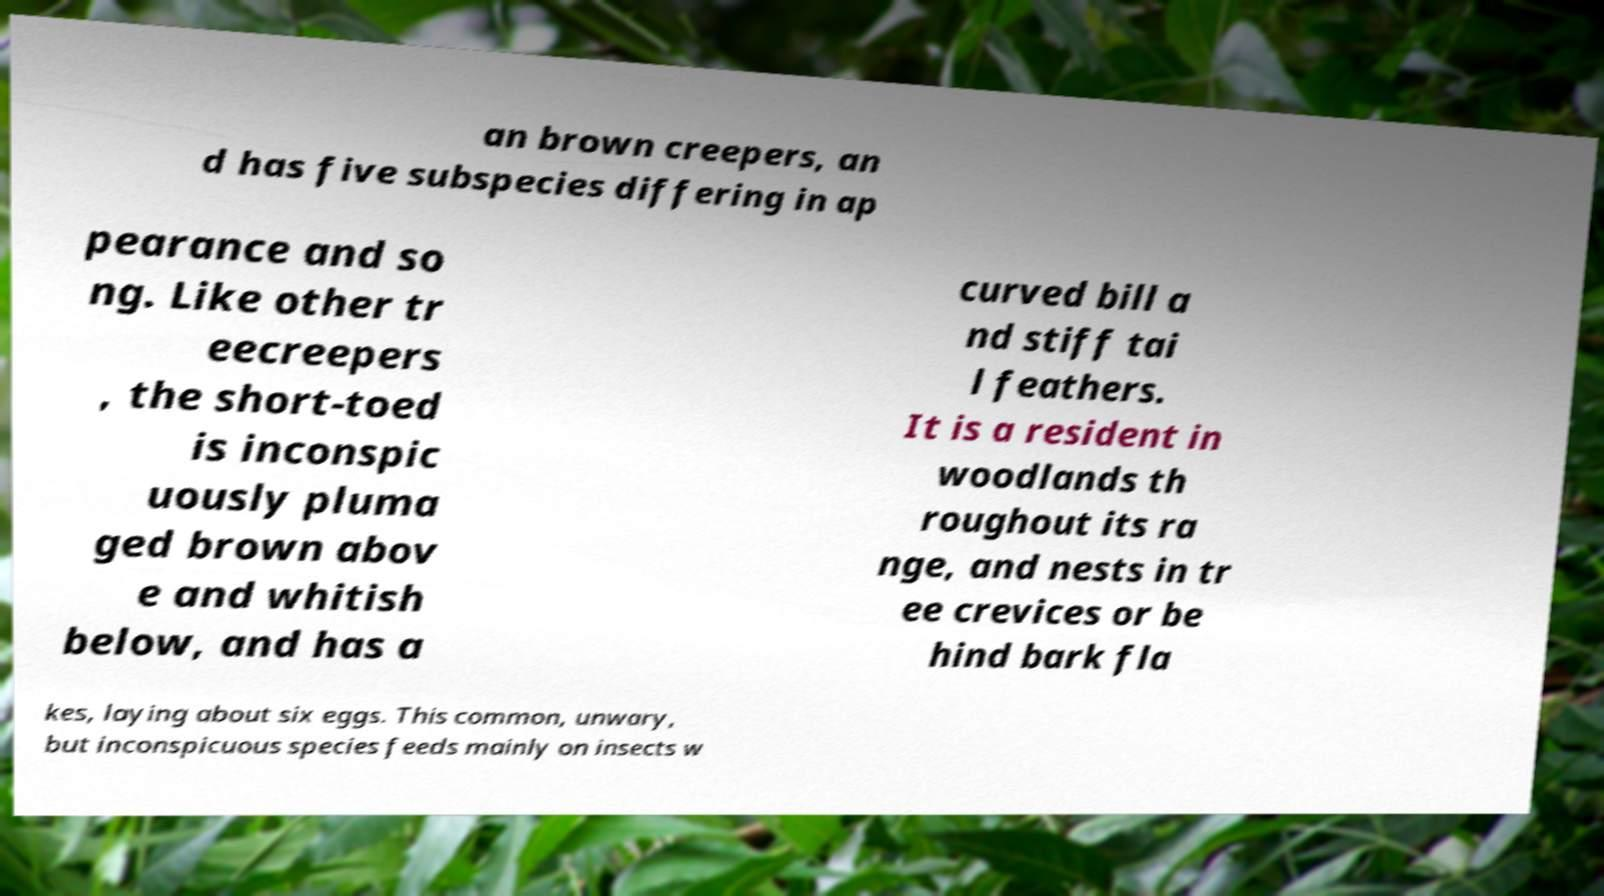Please identify and transcribe the text found in this image. an brown creepers, an d has five subspecies differing in ap pearance and so ng. Like other tr eecreepers , the short-toed is inconspic uously pluma ged brown abov e and whitish below, and has a curved bill a nd stiff tai l feathers. It is a resident in woodlands th roughout its ra nge, and nests in tr ee crevices or be hind bark fla kes, laying about six eggs. This common, unwary, but inconspicuous species feeds mainly on insects w 